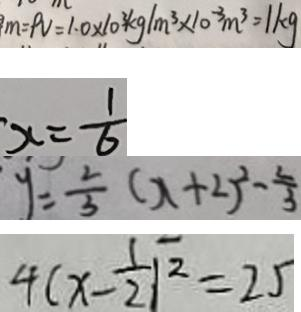<formula> <loc_0><loc_0><loc_500><loc_500>m = P v = 1 . 0 \times 1 0 ^ { 3 } k g / m ^ { 3 } \times 1 0 ^ { - 3 } m ^ { 3 } = 1 k g 
 x = \frac { 1 } { 6 } 
 y = \frac { 2 } { 3 } ( x + 2 ) ^ { 2 } - \frac { 2 } { 3 } 
 4 ( x - \frac { 1 } { 2 } ) ^ { 2 } = 2 5</formula> 